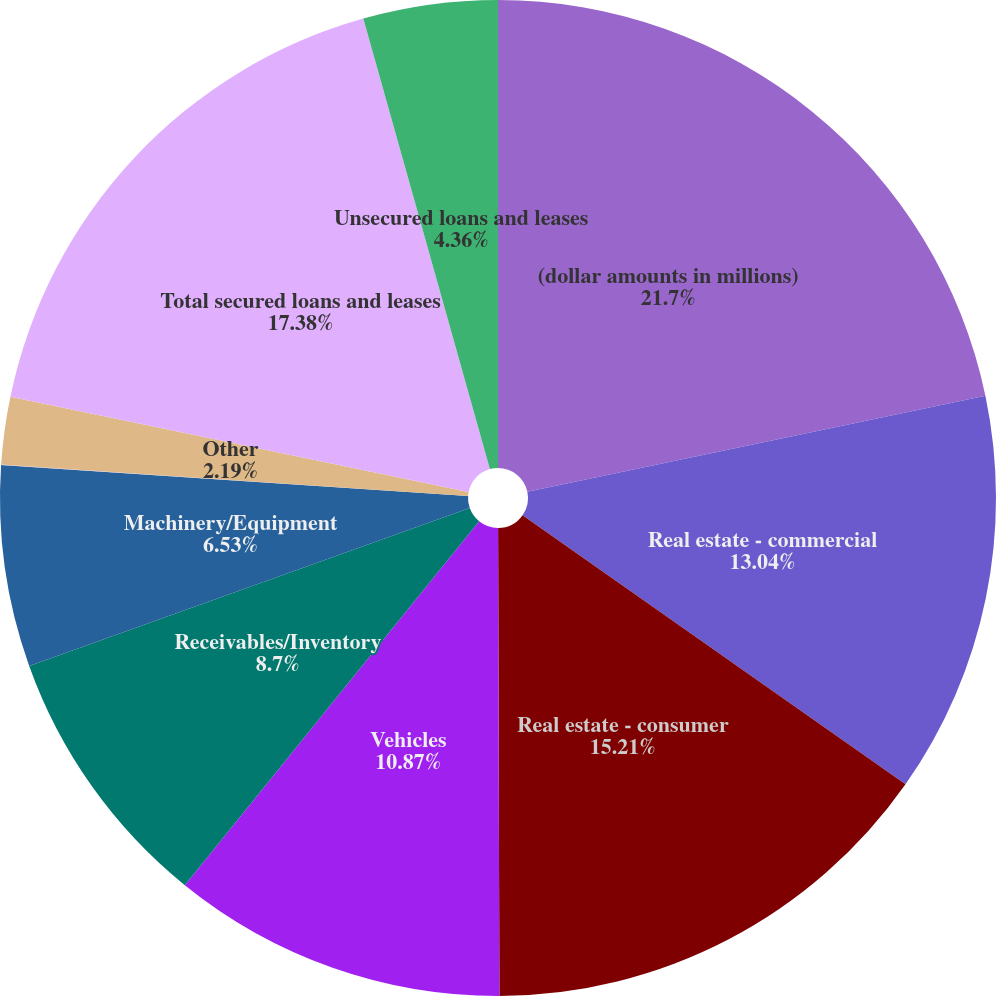Convert chart. <chart><loc_0><loc_0><loc_500><loc_500><pie_chart><fcel>(dollar amounts in millions)<fcel>Real estate - commercial<fcel>Real estate - consumer<fcel>Vehicles<fcel>Receivables/Inventory<fcel>Machinery/Equipment<fcel>Securities/Deposits<fcel>Other<fcel>Total secured loans and leases<fcel>Unsecured loans and leases<nl><fcel>21.71%<fcel>13.04%<fcel>15.21%<fcel>10.87%<fcel>8.7%<fcel>6.53%<fcel>0.02%<fcel>2.19%<fcel>17.38%<fcel>4.36%<nl></chart> 